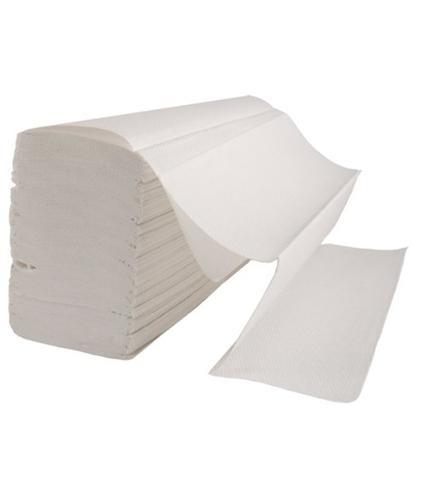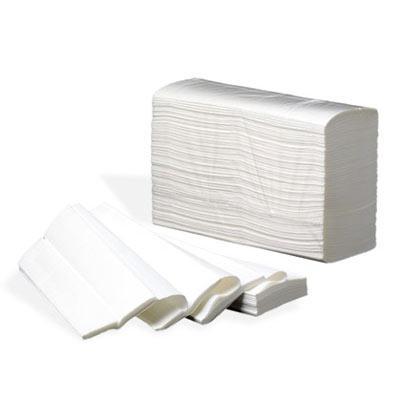The first image is the image on the left, the second image is the image on the right. For the images displayed, is the sentence "An image shows one stack of solid-white folded paper towels displayed at an angle, with the top sheet opening like an accordion and draped over the front of the stack." factually correct? Answer yes or no. Yes. The first image is the image on the left, the second image is the image on the right. For the images shown, is this caption "The left and right image contains a total of two piles of paper towels that have at least 50 sheet." true? Answer yes or no. Yes. 